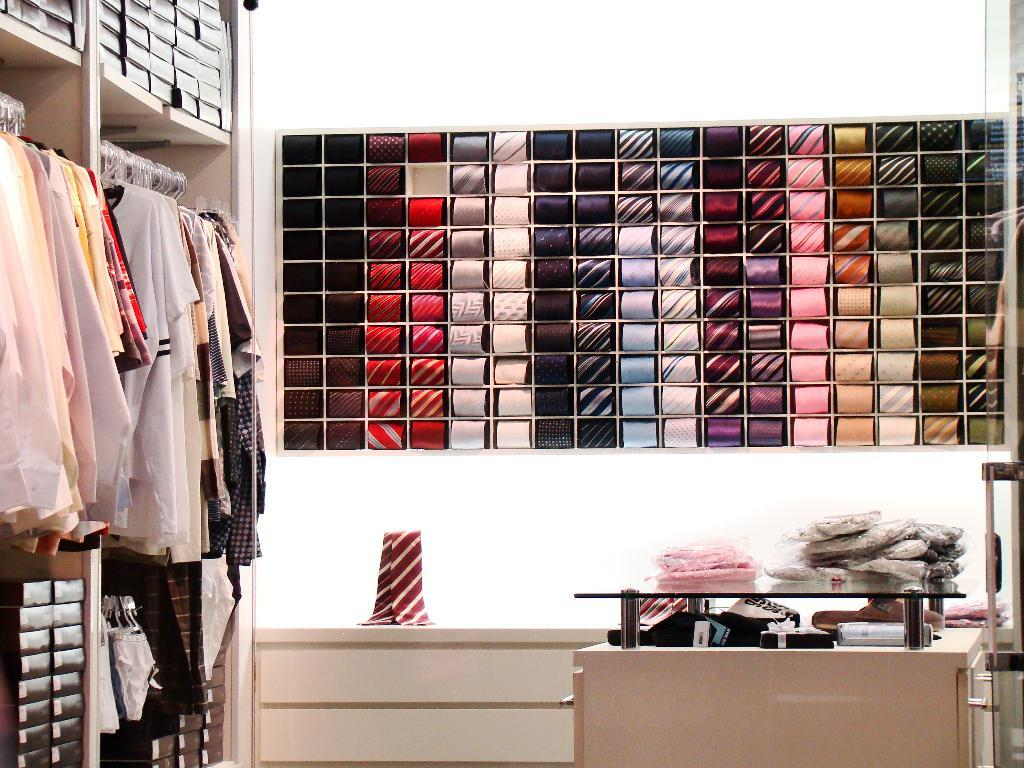What type of clothing items are in the image? There are shirts in the image. How are the shirts arranged in the image? The shirts are hanging on a hanger. What other accessories can be seen in the image? There are ties in the image. Can you describe the variety of ties in the image? There is a variety of ties in the image. What type of polish is being applied to the shirts in the image? There is no polish being applied to the shirts in the image; they are simply hanging on a hanger. 